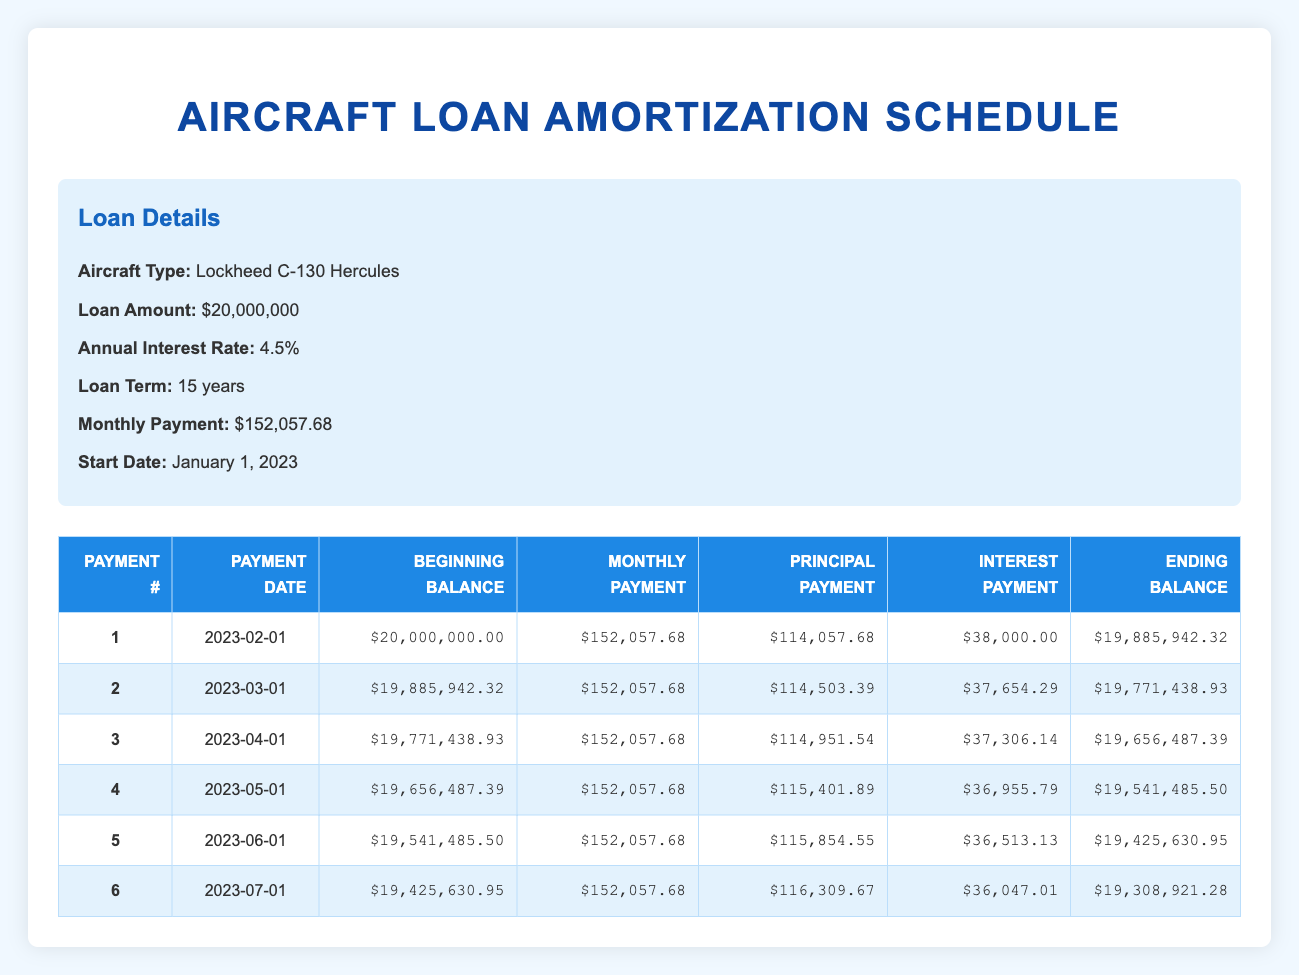What is the monthly payment for the aircraft loan? The monthly payment is explicitly stated in the loan details section of the table as $152,057.68.
Answer: 152057.68 What is the total interest payment for the first payment? The first payment's interest payment is listed in the table as $38,000.00.
Answer: 38000.00 How much principal is paid off in the second payment? The second payment shows a principal payment of $114,503.39. This value is directly taken from the table.
Answer: 114503.39 What is the ending balance after the fifth payment? The ending balance after the fifth payment is listed in the table as $19,425,630.95.
Answer: 19425630.95 Is the interest payment for the first payment higher than the interest payment for the second payment? Comparing the interest payments, the first payment is $38,000.00 and the second payment is $37,654.29. Since 38,000.00 > 37,654.29, the statement is true.
Answer: Yes What is the total principal paid off after the first three payments? To calculate the total principal paid after the first three payments, we add the principal payments from those payments: 114057.68 + 114503.39 + 114951.54 = 343512.61.
Answer: 343512.61 What was the beginning balance for the fourth payment? The beginning balance for the fourth payment is the ending balance from the third payment, which is $19,656,487.39, as seen in the table.
Answer: 19656487.39 How much total interest is paid in the first six payments? To find the total interest for the first six payments, we sum the interest payments: 38000.00 + 37654.29 + 37306.14 + 36955.79 + 36513.13 + 36047.01 = 219476.36. This calculation involves adding the interest from each payment.
Answer: 219476.36 Is the decrease in the ending balance from the first to the second payment greater than $150,000? The ending balance decreased from $19,885,942.32 to $19,771,438.93, which is a decrease of $114,503.39. Since $114,503.39 < $150,000, the statement is false.
Answer: No 